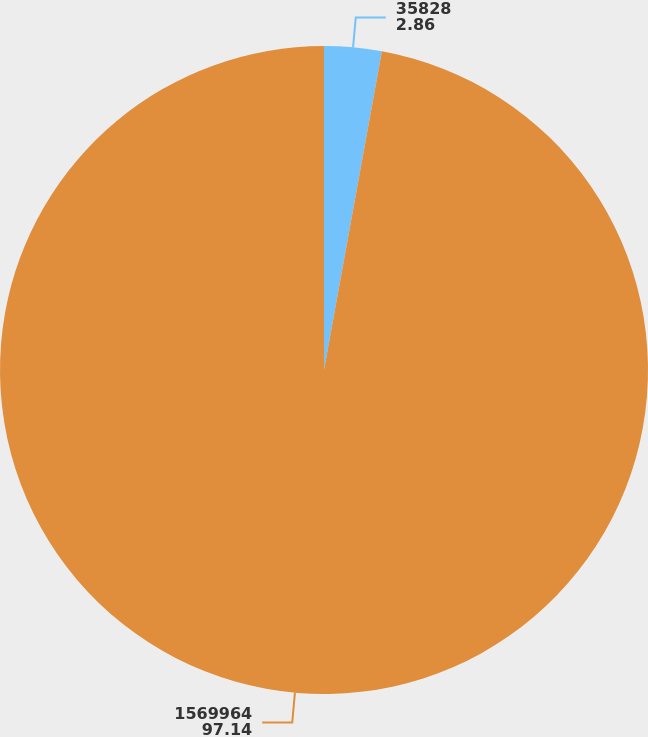Convert chart. <chart><loc_0><loc_0><loc_500><loc_500><pie_chart><fcel>35828<fcel>1569964<nl><fcel>2.86%<fcel>97.14%<nl></chart> 